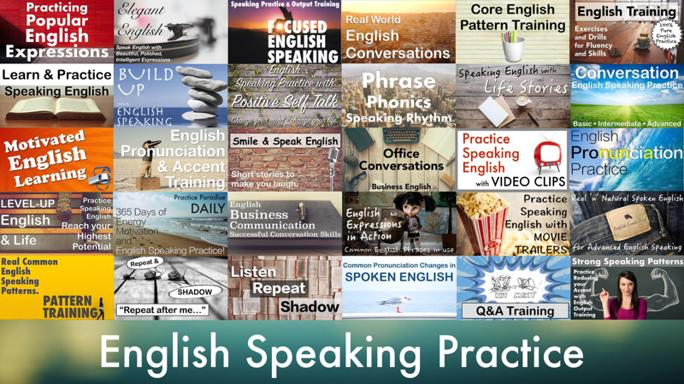What is common among the phrases in the image? The common theme among the phrases visible in the image is centered around techniques and resources for improving English speaking skills. These include methods and educational tools aimed at enhancing fluency, pronunciation, and practical usage of English. 